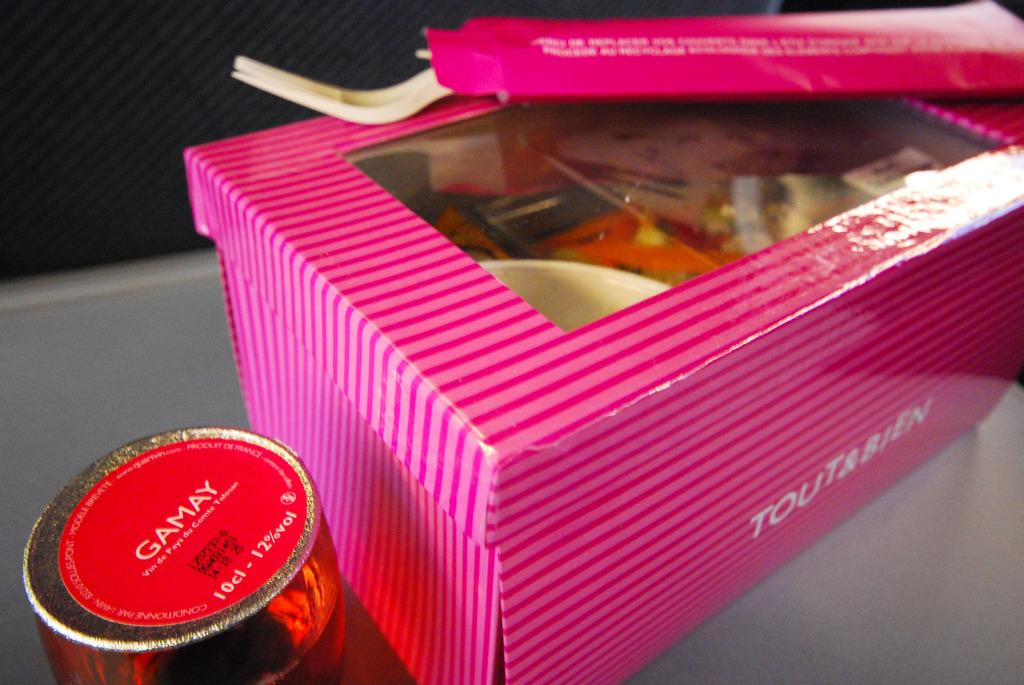What type of containers are present in the image? There are boxes with lids in the image. Can you describe the utensil that is visible in the image? There is a fork on a cardboard box in the image. What is the unspecified object in the image? Unfortunately, the facts provided do not give any details about the unspecified object. How many tails can be seen on the objects in the image? There are no tails visible on any objects in the image. What type of glove is present in the image? There is no glove present in the image. 